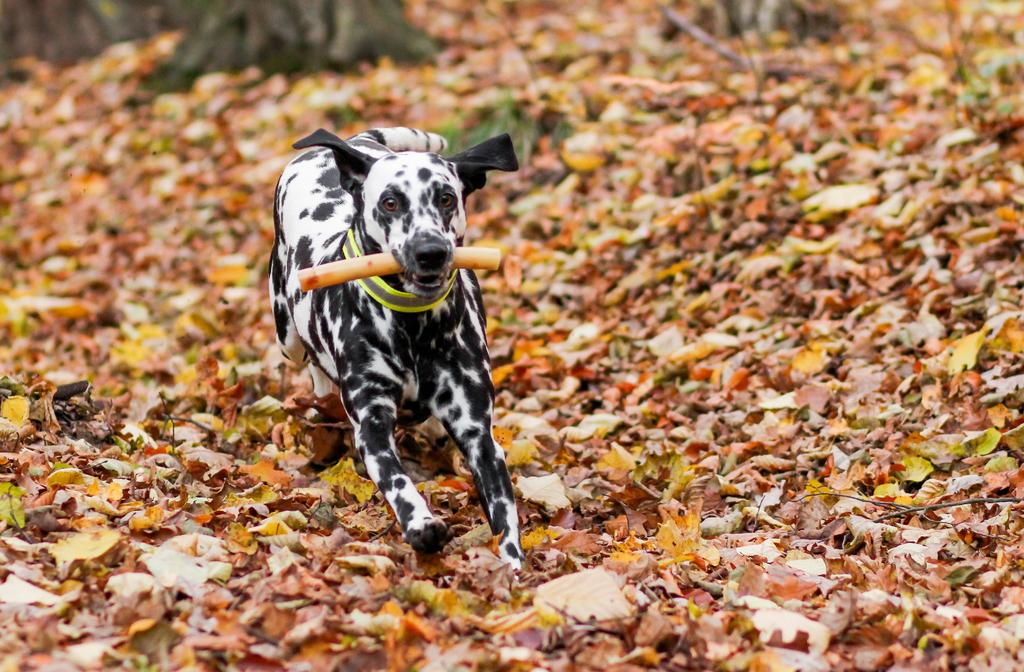What is the main subject in the foreground of the image? There is a dog in the foreground of the image. What is the dog doing in the image? The dog is running. What is the dog holding in its mouth? The dog is holding something in its mouth. What can be seen on the ground in the image? There are dry fruit leaves on the ground in the image. What type of guitar is the dog playing in the image? There is no guitar present in the image, and the dog is not playing any instrument. 